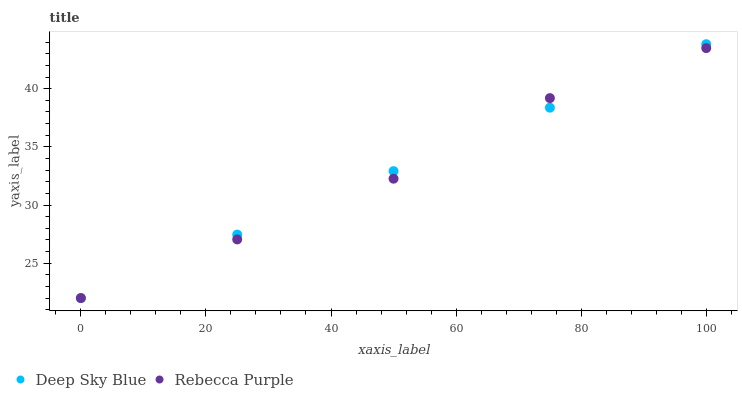Does Rebecca Purple have the minimum area under the curve?
Answer yes or no. Yes. Does Deep Sky Blue have the maximum area under the curve?
Answer yes or no. Yes. Does Deep Sky Blue have the minimum area under the curve?
Answer yes or no. No. Is Deep Sky Blue the smoothest?
Answer yes or no. Yes. Is Rebecca Purple the roughest?
Answer yes or no. Yes. Is Deep Sky Blue the roughest?
Answer yes or no. No. Does Rebecca Purple have the lowest value?
Answer yes or no. Yes. Does Deep Sky Blue have the highest value?
Answer yes or no. Yes. Does Rebecca Purple intersect Deep Sky Blue?
Answer yes or no. Yes. Is Rebecca Purple less than Deep Sky Blue?
Answer yes or no. No. Is Rebecca Purple greater than Deep Sky Blue?
Answer yes or no. No. 